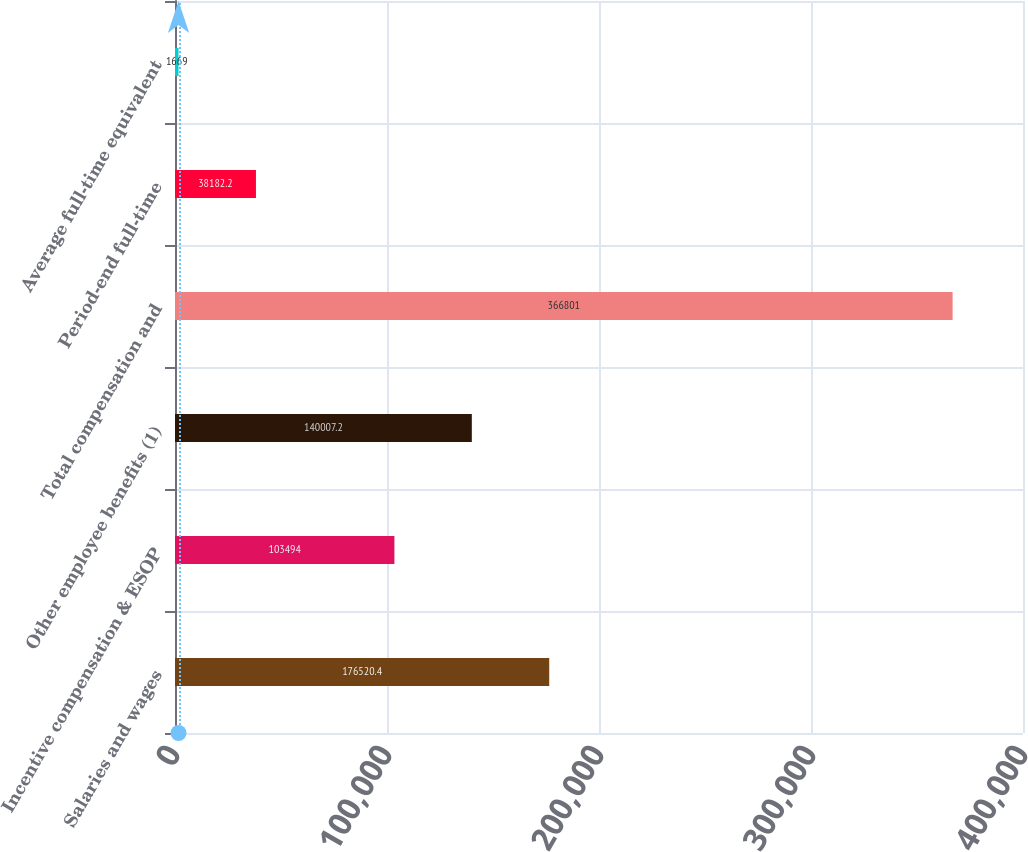Convert chart. <chart><loc_0><loc_0><loc_500><loc_500><bar_chart><fcel>Salaries and wages<fcel>Incentive compensation & ESOP<fcel>Other employee benefits (1)<fcel>Total compensation and<fcel>Period-end full-time<fcel>Average full-time equivalent<nl><fcel>176520<fcel>103494<fcel>140007<fcel>366801<fcel>38182.2<fcel>1669<nl></chart> 